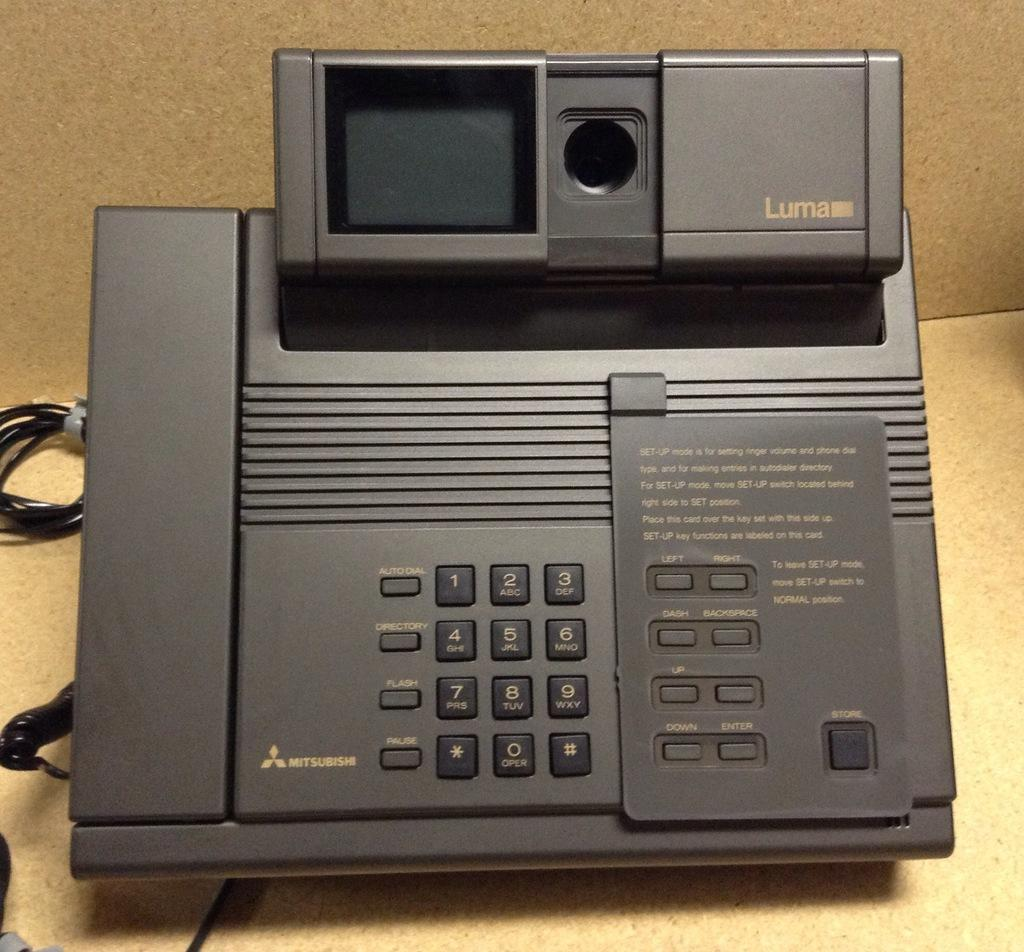What device is the main subject of the image? There is an answering machine in the image. What is the color of the answering machine? The answering machine is black in color. What feature is present on the answering machine for interacting with it? There are buttons attached to the answering machine. What else can be seen in the image besides the answering machine? There are wires visible in the image. Can you tell me how many turkeys are sitting on the minister's wheel in the image? There are no turkeys, ministers, or wheels present in the image; it features an answering machine with buttons and wires. 